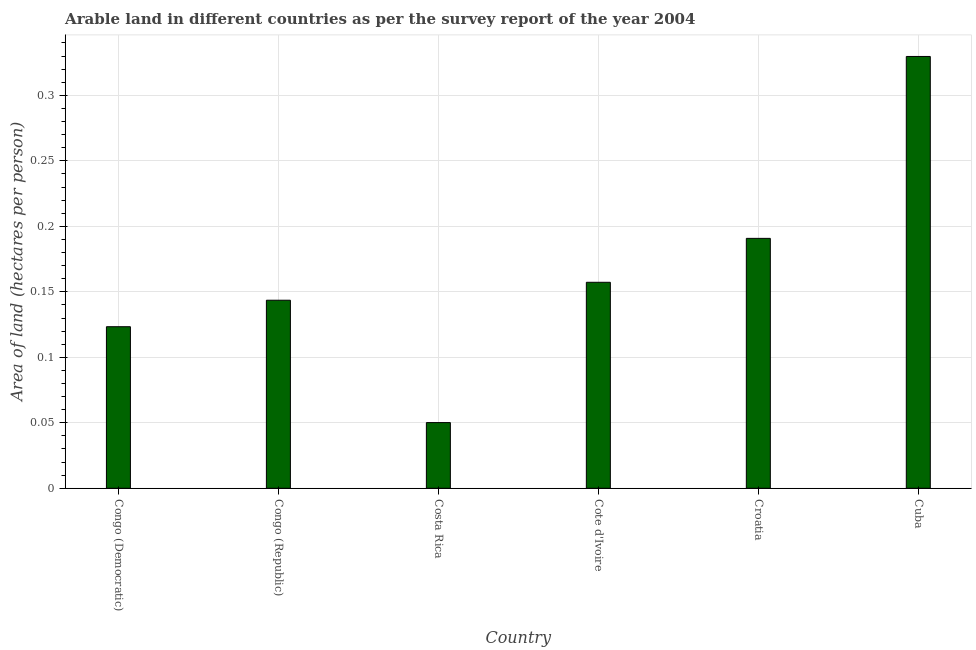What is the title of the graph?
Your answer should be compact. Arable land in different countries as per the survey report of the year 2004. What is the label or title of the X-axis?
Your answer should be compact. Country. What is the label or title of the Y-axis?
Offer a terse response. Area of land (hectares per person). What is the area of arable land in Cote d'Ivoire?
Ensure brevity in your answer.  0.16. Across all countries, what is the maximum area of arable land?
Provide a short and direct response. 0.33. Across all countries, what is the minimum area of arable land?
Your answer should be compact. 0.05. In which country was the area of arable land maximum?
Your response must be concise. Cuba. In which country was the area of arable land minimum?
Your response must be concise. Costa Rica. What is the sum of the area of arable land?
Your response must be concise. 0.99. What is the difference between the area of arable land in Costa Rica and Cote d'Ivoire?
Your answer should be very brief. -0.11. What is the average area of arable land per country?
Give a very brief answer. 0.17. What is the median area of arable land?
Make the answer very short. 0.15. What is the ratio of the area of arable land in Congo (Democratic) to that in Congo (Republic)?
Your answer should be compact. 0.86. Is the difference between the area of arable land in Congo (Democratic) and Cuba greater than the difference between any two countries?
Your answer should be very brief. No. What is the difference between the highest and the second highest area of arable land?
Make the answer very short. 0.14. What is the difference between the highest and the lowest area of arable land?
Your response must be concise. 0.28. How many bars are there?
Your response must be concise. 6. Are all the bars in the graph horizontal?
Your answer should be very brief. No. How many countries are there in the graph?
Give a very brief answer. 6. Are the values on the major ticks of Y-axis written in scientific E-notation?
Your answer should be very brief. No. What is the Area of land (hectares per person) of Congo (Democratic)?
Keep it short and to the point. 0.12. What is the Area of land (hectares per person) of Congo (Republic)?
Offer a terse response. 0.14. What is the Area of land (hectares per person) in Costa Rica?
Give a very brief answer. 0.05. What is the Area of land (hectares per person) of Cote d'Ivoire?
Keep it short and to the point. 0.16. What is the Area of land (hectares per person) of Croatia?
Offer a terse response. 0.19. What is the Area of land (hectares per person) in Cuba?
Make the answer very short. 0.33. What is the difference between the Area of land (hectares per person) in Congo (Democratic) and Congo (Republic)?
Provide a short and direct response. -0.02. What is the difference between the Area of land (hectares per person) in Congo (Democratic) and Costa Rica?
Your response must be concise. 0.07. What is the difference between the Area of land (hectares per person) in Congo (Democratic) and Cote d'Ivoire?
Provide a short and direct response. -0.03. What is the difference between the Area of land (hectares per person) in Congo (Democratic) and Croatia?
Provide a succinct answer. -0.07. What is the difference between the Area of land (hectares per person) in Congo (Democratic) and Cuba?
Your response must be concise. -0.21. What is the difference between the Area of land (hectares per person) in Congo (Republic) and Costa Rica?
Make the answer very short. 0.09. What is the difference between the Area of land (hectares per person) in Congo (Republic) and Cote d'Ivoire?
Give a very brief answer. -0.01. What is the difference between the Area of land (hectares per person) in Congo (Republic) and Croatia?
Your answer should be very brief. -0.05. What is the difference between the Area of land (hectares per person) in Congo (Republic) and Cuba?
Your answer should be compact. -0.19. What is the difference between the Area of land (hectares per person) in Costa Rica and Cote d'Ivoire?
Provide a succinct answer. -0.11. What is the difference between the Area of land (hectares per person) in Costa Rica and Croatia?
Your answer should be compact. -0.14. What is the difference between the Area of land (hectares per person) in Costa Rica and Cuba?
Your answer should be very brief. -0.28. What is the difference between the Area of land (hectares per person) in Cote d'Ivoire and Croatia?
Ensure brevity in your answer.  -0.03. What is the difference between the Area of land (hectares per person) in Cote d'Ivoire and Cuba?
Offer a terse response. -0.17. What is the difference between the Area of land (hectares per person) in Croatia and Cuba?
Offer a very short reply. -0.14. What is the ratio of the Area of land (hectares per person) in Congo (Democratic) to that in Congo (Republic)?
Keep it short and to the point. 0.86. What is the ratio of the Area of land (hectares per person) in Congo (Democratic) to that in Costa Rica?
Your response must be concise. 2.46. What is the ratio of the Area of land (hectares per person) in Congo (Democratic) to that in Cote d'Ivoire?
Offer a very short reply. 0.78. What is the ratio of the Area of land (hectares per person) in Congo (Democratic) to that in Croatia?
Your answer should be compact. 0.65. What is the ratio of the Area of land (hectares per person) in Congo (Democratic) to that in Cuba?
Offer a very short reply. 0.37. What is the ratio of the Area of land (hectares per person) in Congo (Republic) to that in Costa Rica?
Make the answer very short. 2.86. What is the ratio of the Area of land (hectares per person) in Congo (Republic) to that in Cote d'Ivoire?
Provide a succinct answer. 0.91. What is the ratio of the Area of land (hectares per person) in Congo (Republic) to that in Croatia?
Your response must be concise. 0.75. What is the ratio of the Area of land (hectares per person) in Congo (Republic) to that in Cuba?
Give a very brief answer. 0.44. What is the ratio of the Area of land (hectares per person) in Costa Rica to that in Cote d'Ivoire?
Make the answer very short. 0.32. What is the ratio of the Area of land (hectares per person) in Costa Rica to that in Croatia?
Your answer should be compact. 0.26. What is the ratio of the Area of land (hectares per person) in Costa Rica to that in Cuba?
Give a very brief answer. 0.15. What is the ratio of the Area of land (hectares per person) in Cote d'Ivoire to that in Croatia?
Provide a short and direct response. 0.82. What is the ratio of the Area of land (hectares per person) in Cote d'Ivoire to that in Cuba?
Your answer should be very brief. 0.48. What is the ratio of the Area of land (hectares per person) in Croatia to that in Cuba?
Ensure brevity in your answer.  0.58. 